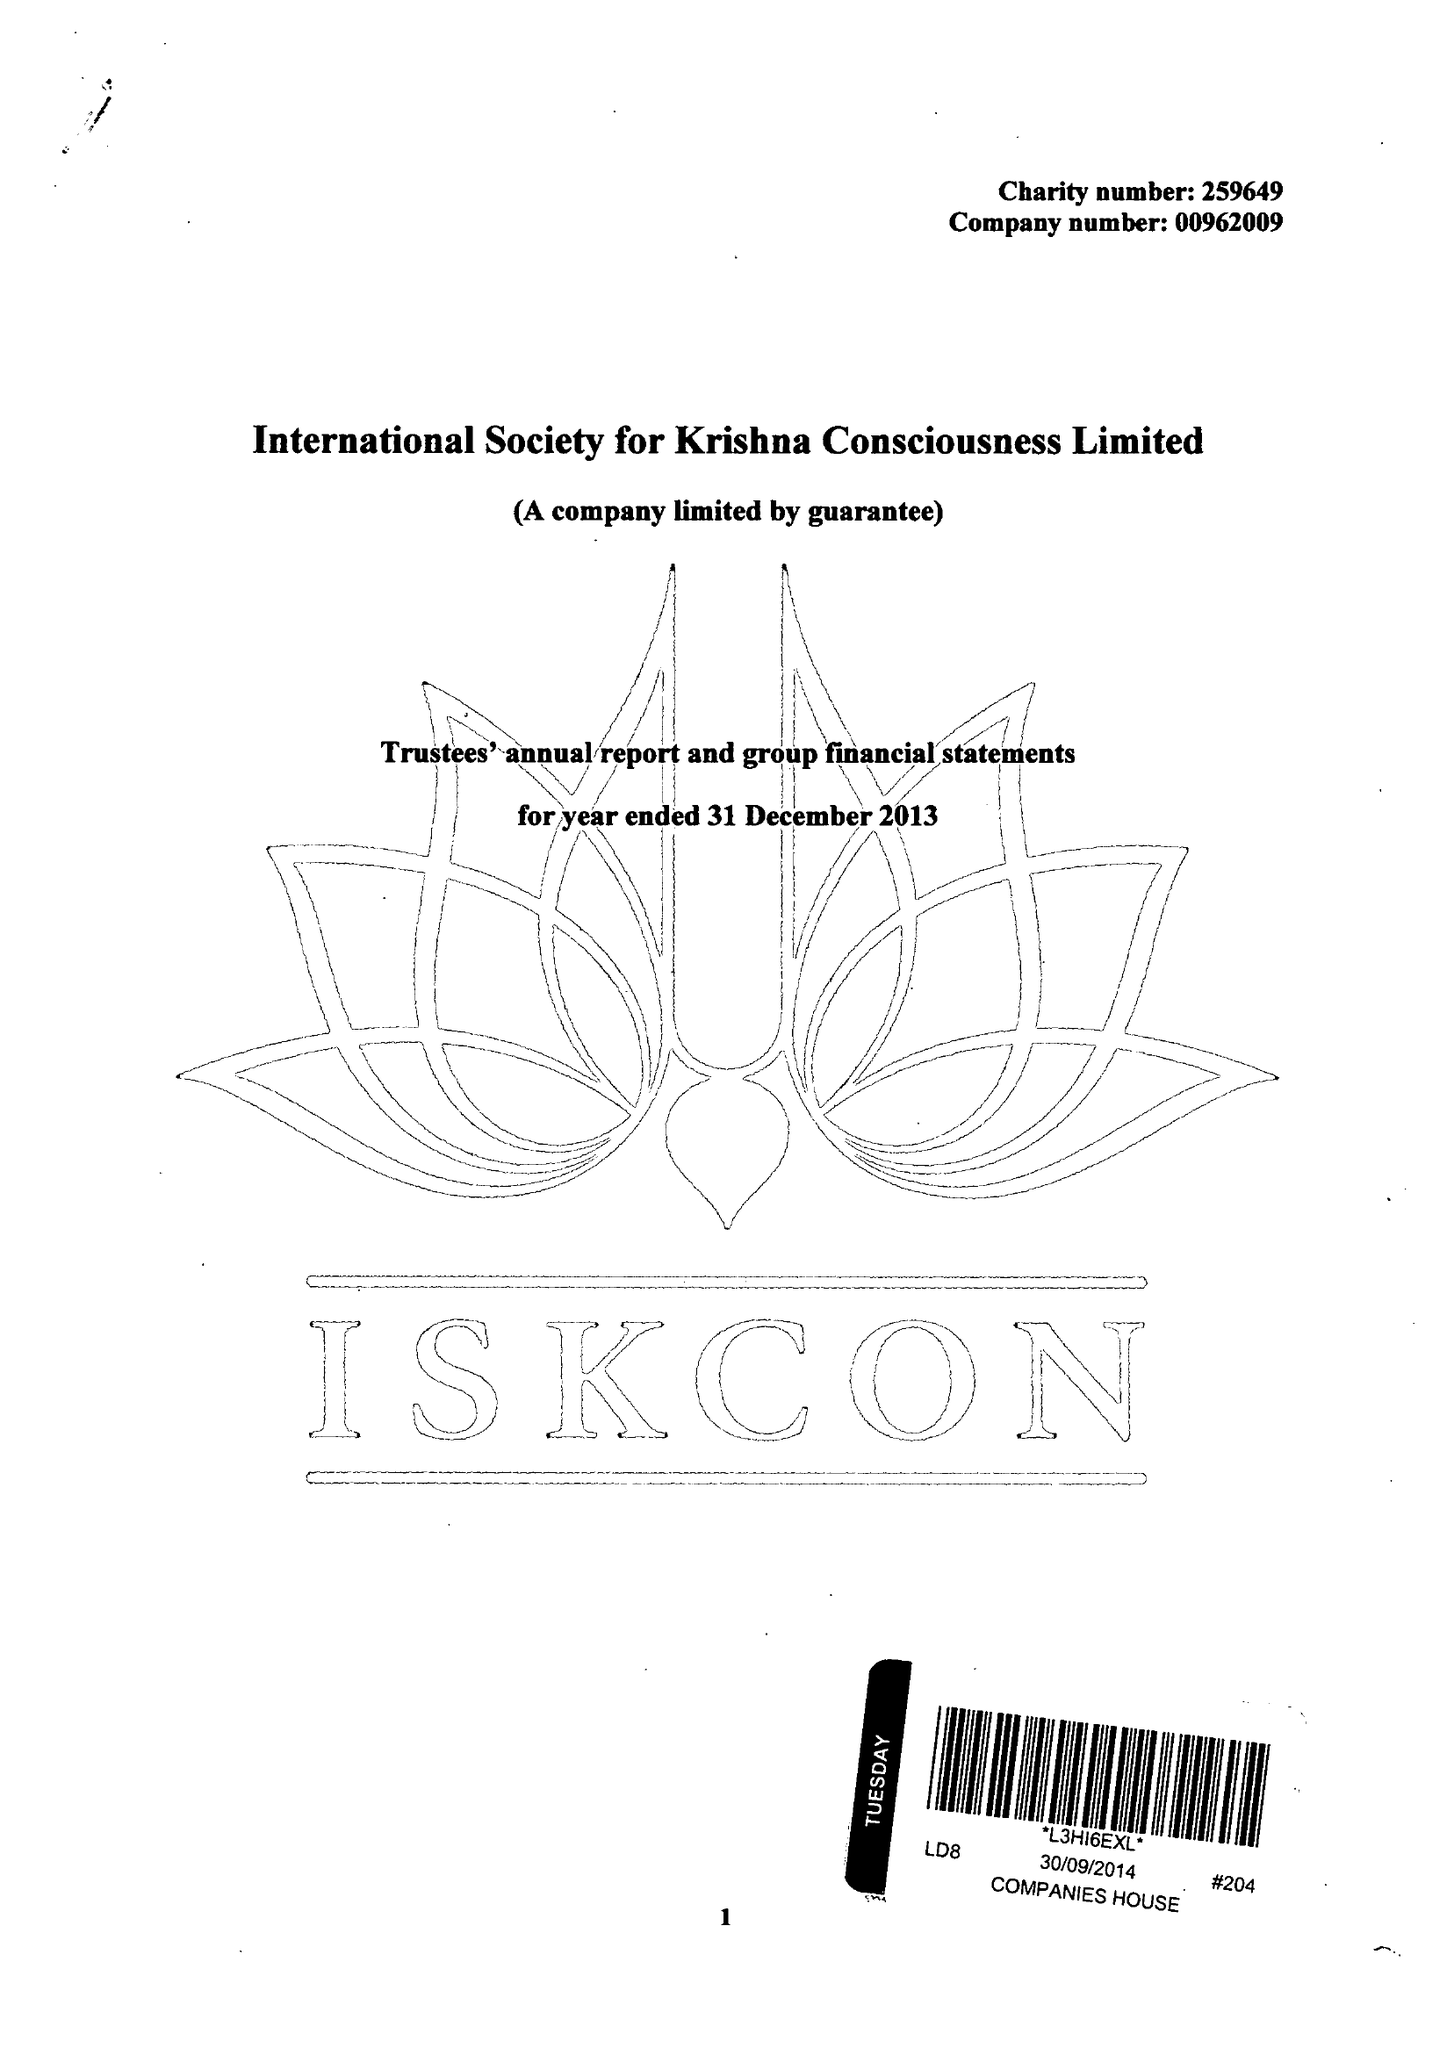What is the value for the income_annually_in_british_pounds?
Answer the question using a single word or phrase. 6198254.00 